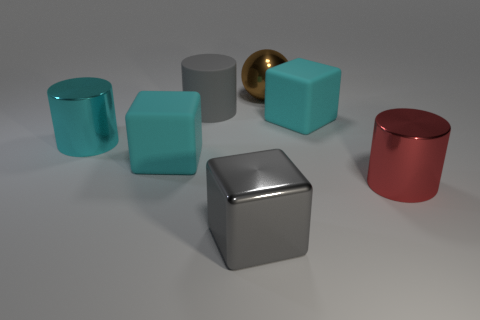Subtract all brown spheres. How many cyan blocks are left? 2 Add 1 big cylinders. How many objects exist? 8 Subtract all blocks. How many objects are left? 4 Subtract 0 brown cylinders. How many objects are left? 7 Subtract all tiny blue matte blocks. Subtract all big gray cylinders. How many objects are left? 6 Add 7 cyan cylinders. How many cyan cylinders are left? 8 Add 2 yellow cylinders. How many yellow cylinders exist? 2 